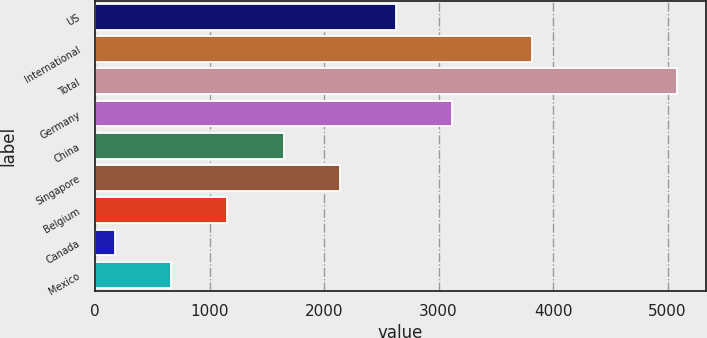Convert chart. <chart><loc_0><loc_0><loc_500><loc_500><bar_chart><fcel>US<fcel>International<fcel>Total<fcel>Germany<fcel>China<fcel>Singapore<fcel>Belgium<fcel>Canada<fcel>Mexico<nl><fcel>2627.5<fcel>3820<fcel>5082<fcel>3118.4<fcel>1645.7<fcel>2136.6<fcel>1154.8<fcel>173<fcel>663.9<nl></chart> 